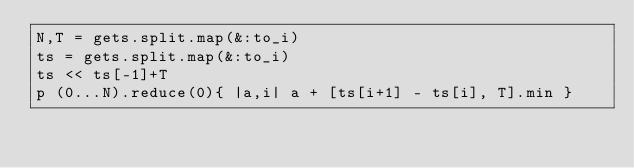Convert code to text. <code><loc_0><loc_0><loc_500><loc_500><_Ruby_>N,T = gets.split.map(&:to_i)
ts = gets.split.map(&:to_i)
ts << ts[-1]+T
p (0...N).reduce(0){ |a,i| a + [ts[i+1] - ts[i], T].min }</code> 